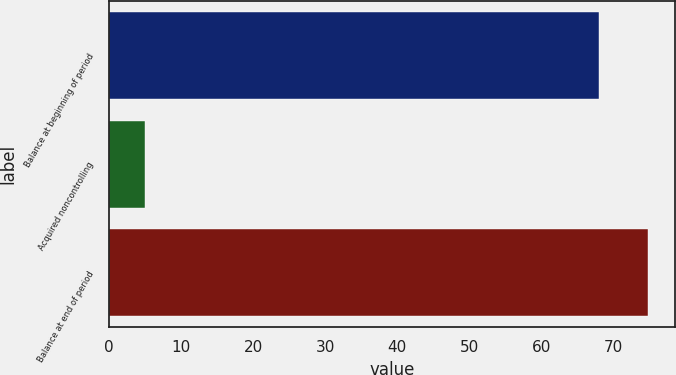Convert chart. <chart><loc_0><loc_0><loc_500><loc_500><bar_chart><fcel>Balance at beginning of period<fcel>Acquired noncontrolling<fcel>Balance at end of period<nl><fcel>68<fcel>5<fcel>74.8<nl></chart> 